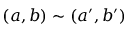Convert formula to latex. <formula><loc_0><loc_0><loc_500><loc_500>( a , b ) \sim ( a ^ { \prime } , b ^ { \prime } )</formula> 